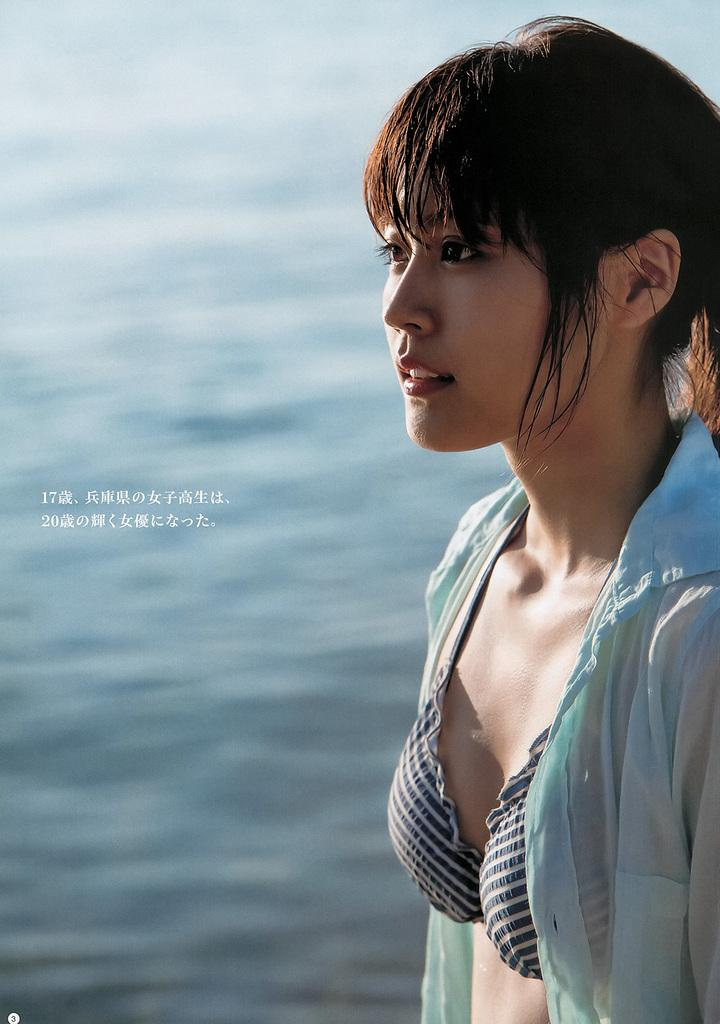What is depicted on the right side of the image? There is a picture of a woman on the right side of the image. What can be seen in the background of the image? There is a surface of water in the background of the image. What type of toy is floating on the water in the image? There is no toy present in the image; it only features a picture of a woman and a surface of water in the background. 